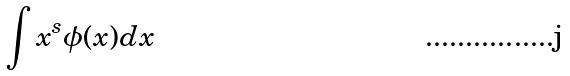Convert formula to latex. <formula><loc_0><loc_0><loc_500><loc_500>\int x ^ { s } \phi ( x ) d x</formula> 